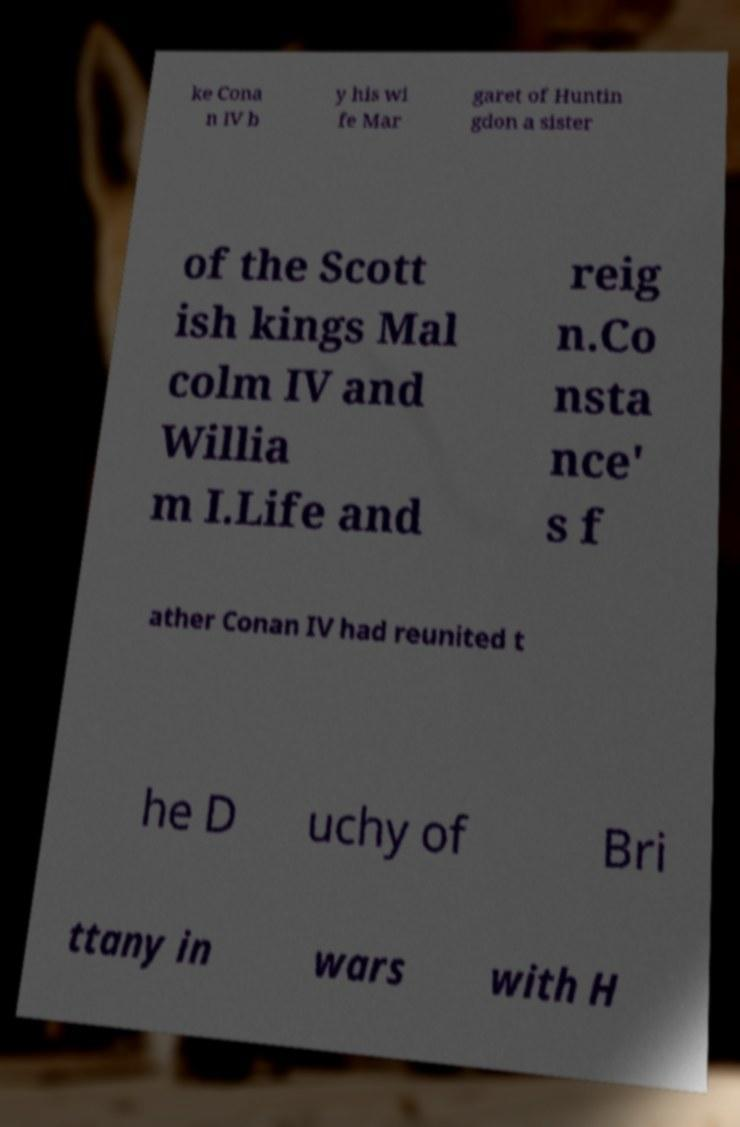There's text embedded in this image that I need extracted. Can you transcribe it verbatim? ke Cona n IV b y his wi fe Mar garet of Huntin gdon a sister of the Scott ish kings Mal colm IV and Willia m I.Life and reig n.Co nsta nce' s f ather Conan IV had reunited t he D uchy of Bri ttany in wars with H 